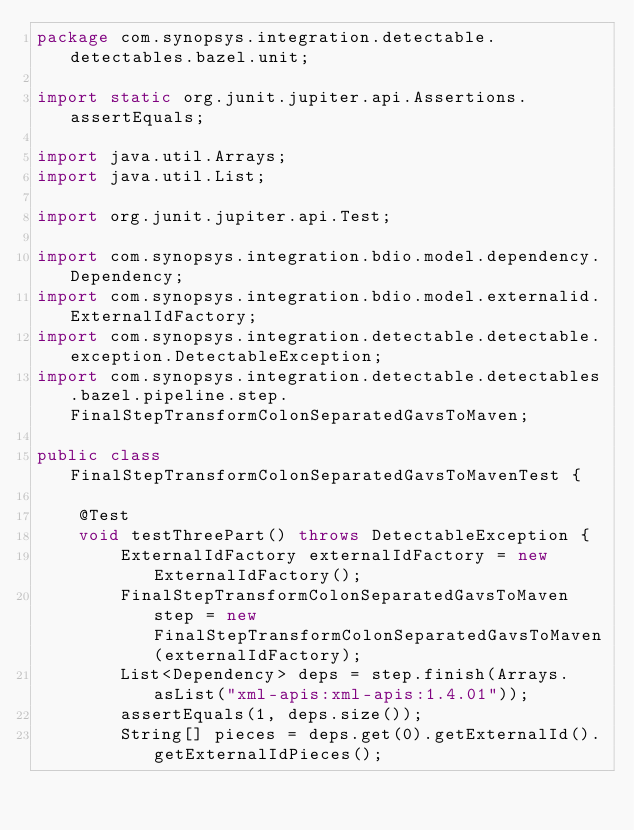Convert code to text. <code><loc_0><loc_0><loc_500><loc_500><_Java_>package com.synopsys.integration.detectable.detectables.bazel.unit;

import static org.junit.jupiter.api.Assertions.assertEquals;

import java.util.Arrays;
import java.util.List;

import org.junit.jupiter.api.Test;

import com.synopsys.integration.bdio.model.dependency.Dependency;
import com.synopsys.integration.bdio.model.externalid.ExternalIdFactory;
import com.synopsys.integration.detectable.detectable.exception.DetectableException;
import com.synopsys.integration.detectable.detectables.bazel.pipeline.step.FinalStepTransformColonSeparatedGavsToMaven;

public class FinalStepTransformColonSeparatedGavsToMavenTest {

    @Test
    void testThreePart() throws DetectableException {
        ExternalIdFactory externalIdFactory = new ExternalIdFactory();
        FinalStepTransformColonSeparatedGavsToMaven step = new FinalStepTransformColonSeparatedGavsToMaven(externalIdFactory);
        List<Dependency> deps = step.finish(Arrays.asList("xml-apis:xml-apis:1.4.01"));
        assertEquals(1, deps.size());
        String[] pieces = deps.get(0).getExternalId().getExternalIdPieces();</code> 